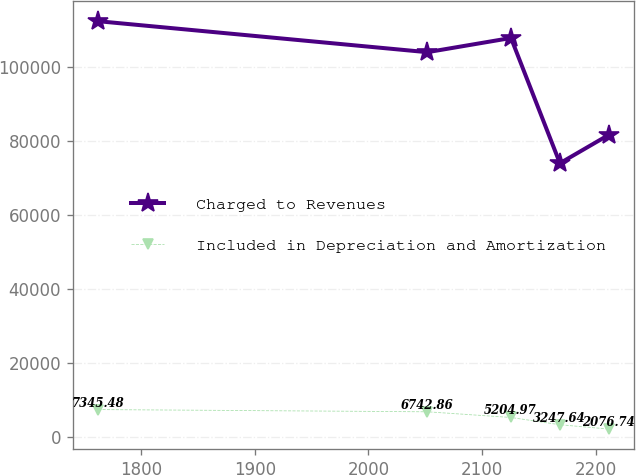Convert chart to OTSL. <chart><loc_0><loc_0><loc_500><loc_500><line_chart><ecel><fcel>Charged to Revenues<fcel>Included in Depreciation and Amortization<nl><fcel>1762.26<fcel>112242<fcel>7345.48<nl><fcel>2051.81<fcel>103872<fcel>6742.86<nl><fcel>2125.38<fcel>107709<fcel>5204.97<nl><fcel>2168.39<fcel>73879.2<fcel>3247.64<nl><fcel>2211.4<fcel>81553.4<fcel>2076.74<nl></chart> 